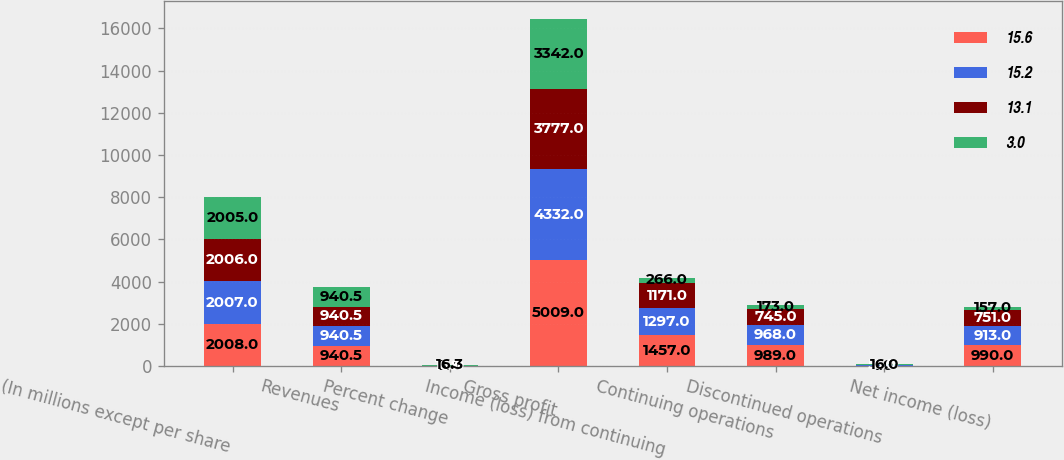Convert chart to OTSL. <chart><loc_0><loc_0><loc_500><loc_500><stacked_bar_chart><ecel><fcel>(In millions except per share<fcel>Revenues<fcel>Percent change<fcel>Gross profit<fcel>Income (loss) from continuing<fcel>Continuing operations<fcel>Discontinued operations<fcel>Net income (loss)<nl><fcel>15.6<fcel>2008<fcel>940.5<fcel>9.4<fcel>5009<fcel>1457<fcel>989<fcel>1<fcel>990<nl><fcel>15.2<fcel>2007<fcel>940.5<fcel>6.9<fcel>4332<fcel>1297<fcel>968<fcel>55<fcel>913<nl><fcel>13.1<fcel>2006<fcel>940.5<fcel>10<fcel>3777<fcel>1171<fcel>745<fcel>6<fcel>751<nl><fcel>3<fcel>2005<fcel>940.5<fcel>16.3<fcel>3342<fcel>266<fcel>173<fcel>16<fcel>157<nl></chart> 